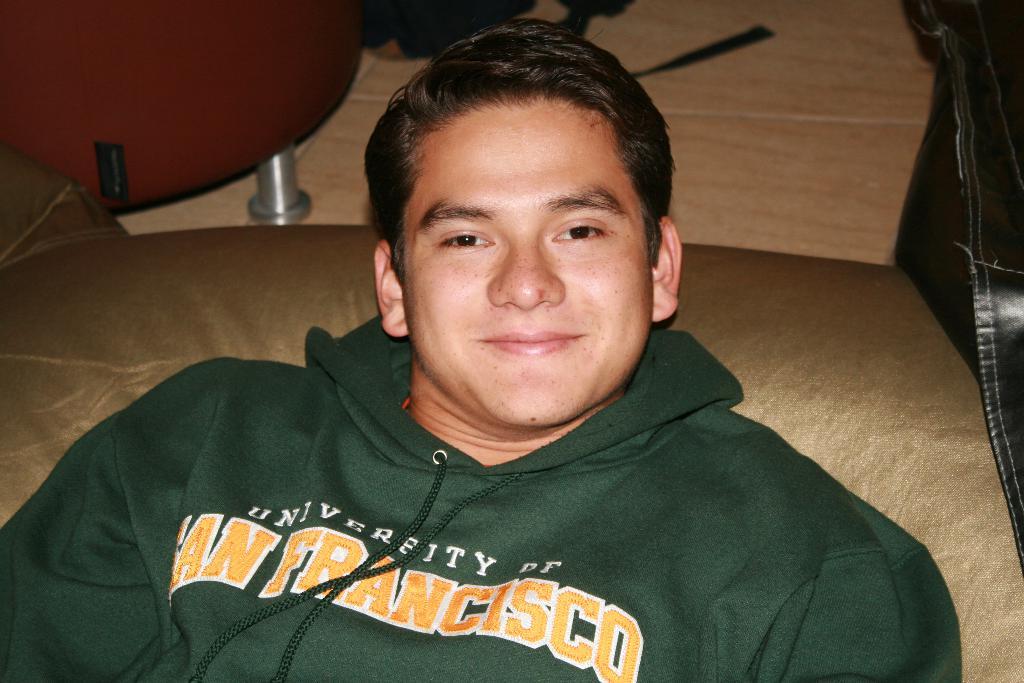What is the university name on the man's sweatshirt?
Your response must be concise. San francisco. 